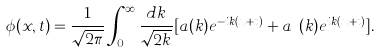<formula> <loc_0><loc_0><loc_500><loc_500>\phi ( x , t ) = \frac { 1 } { \sqrt { 2 \pi } } \int _ { 0 } ^ { \infty } \frac { d k } { \sqrt { 2 k } } [ a ( k ) e ^ { - i k ( x + t ) } + a ^ { \dagger } ( k ) e ^ { i k ( x + t ) } ] .</formula> 